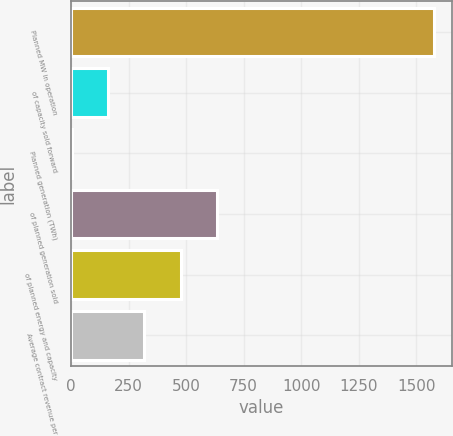Convert chart. <chart><loc_0><loc_0><loc_500><loc_500><bar_chart><fcel>Planned MW in operation<fcel>of capacity sold forward<fcel>Planned generation (TWh)<fcel>of planned generation sold<fcel>of planned energy and capacity<fcel>Average contract revenue per<nl><fcel>1578<fcel>161.4<fcel>4<fcel>633.6<fcel>476.2<fcel>318.8<nl></chart> 